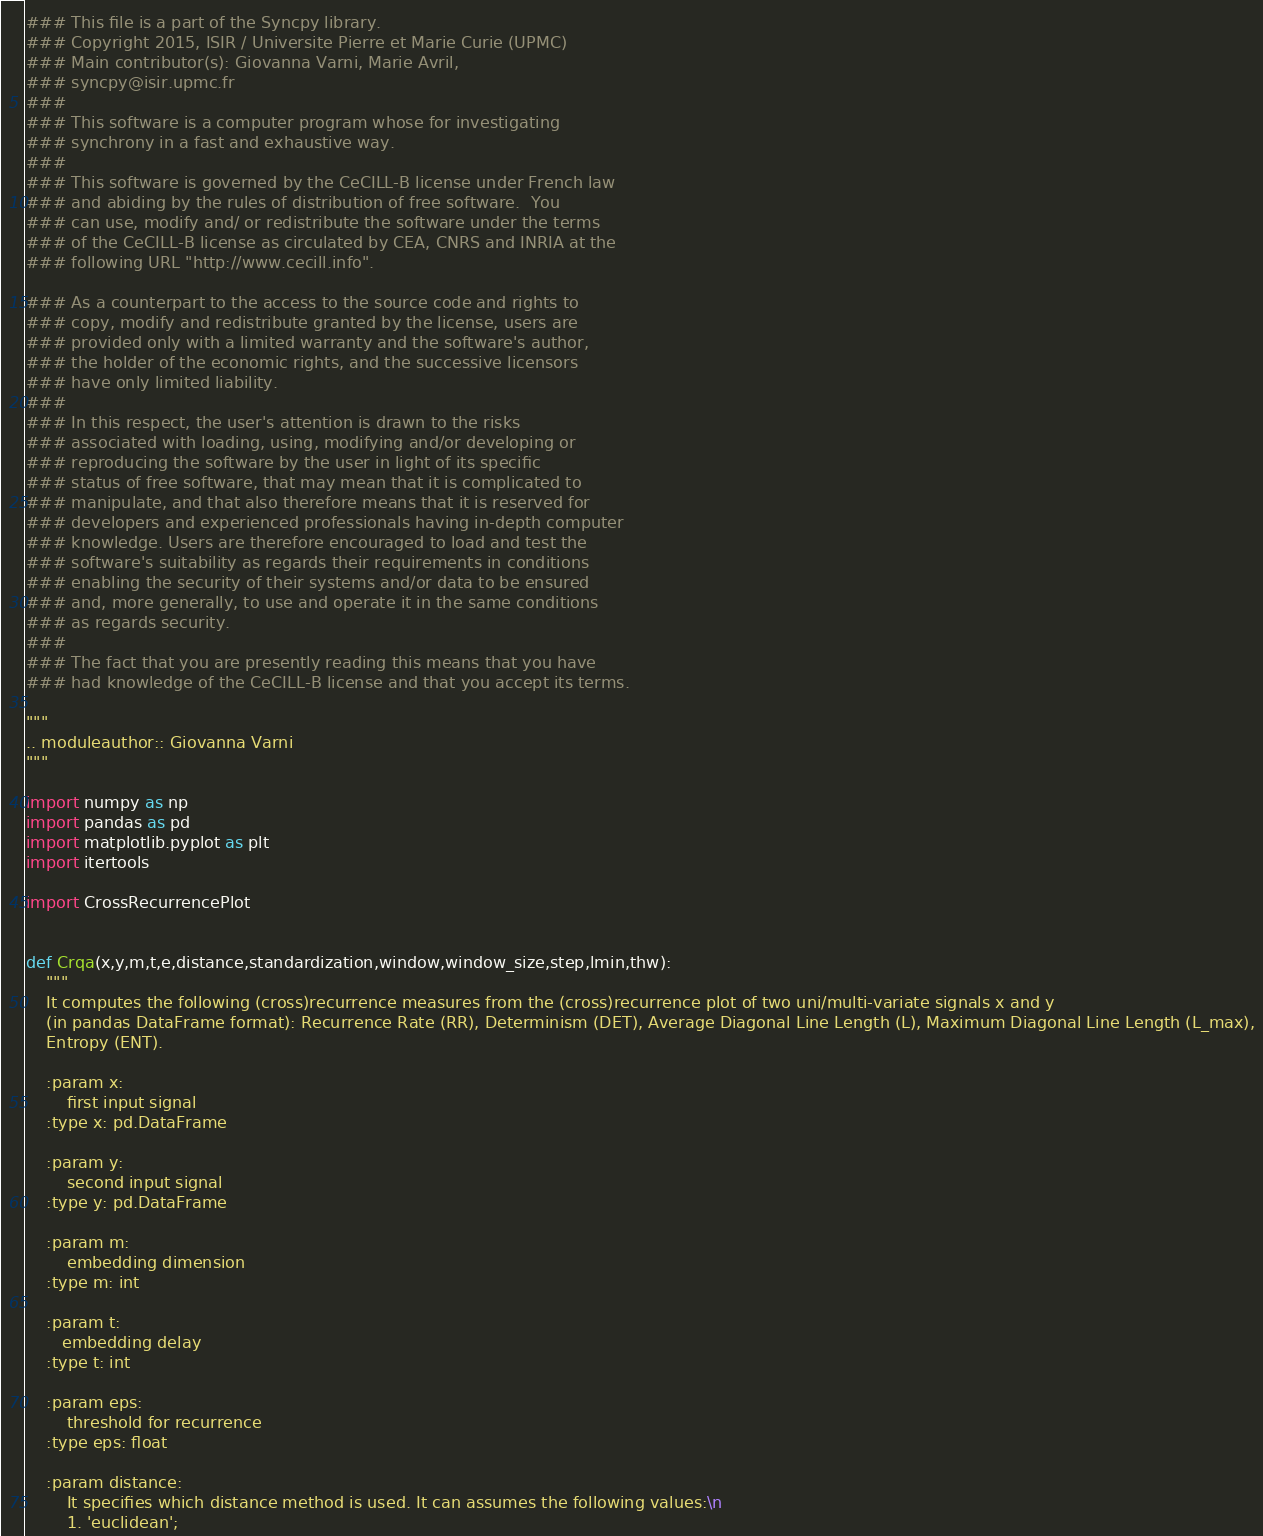<code> <loc_0><loc_0><loc_500><loc_500><_Python_>### This file is a part of the Syncpy library.
### Copyright 2015, ISIR / Universite Pierre et Marie Curie (UPMC)
### Main contributor(s): Giovanna Varni, Marie Avril,
### syncpy@isir.upmc.fr
### 
### This software is a computer program whose for investigating
### synchrony in a fast and exhaustive way. 
### 
### This software is governed by the CeCILL-B license under French law
### and abiding by the rules of distribution of free software.  You
### can use, modify and/ or redistribute the software under the terms
### of the CeCILL-B license as circulated by CEA, CNRS and INRIA at the
### following URL "http://www.cecill.info".

### As a counterpart to the access to the source code and rights to
### copy, modify and redistribute granted by the license, users are
### provided only with a limited warranty and the software's author,
### the holder of the economic rights, and the successive licensors
### have only limited liability.
### 
### In this respect, the user's attention is drawn to the risks
### associated with loading, using, modifying and/or developing or
### reproducing the software by the user in light of its specific
### status of free software, that may mean that it is complicated to
### manipulate, and that also therefore means that it is reserved for
### developers and experienced professionals having in-depth computer
### knowledge. Users are therefore encouraged to load and test the
### software's suitability as regards their requirements in conditions
### enabling the security of their systems and/or data to be ensured
### and, more generally, to use and operate it in the same conditions
### as regards security.
### 
### The fact that you are presently reading this means that you have
### had knowledge of the CeCILL-B license and that you accept its terms.

"""
.. moduleauthor:: Giovanna Varni
"""

import numpy as np
import pandas as pd
import matplotlib.pyplot as plt
import itertools

import CrossRecurrencePlot


def Crqa(x,y,m,t,e,distance,standardization,window,window_size,step,lmin,thw):
    """
    It computes the following (cross)recurrence measures from the (cross)recurrence plot of two uni/multi-variate signals x and y
    (in pandas DataFrame format): Recurrence Rate (RR), Determinism (DET), Average Diagonal Line Length (L), Maximum Diagonal Line Length (L_max),
    Entropy (ENT).
    
    :param x:
        first input signal
    :type x: pd.DataFrame
    
    :param y:
        second input signal
    :type y: pd.DataFrame
    
    :param m:
        embedding dimension
    :type m: int
    
    :param t:
       embedding delay
    :type t: int
    
    :param eps:
        threshold for recurrence
    :type eps: float    
    
    :param distance:
        It specifies which distance method is used. It can assumes the following values:\n
        1. 'euclidean';</code> 